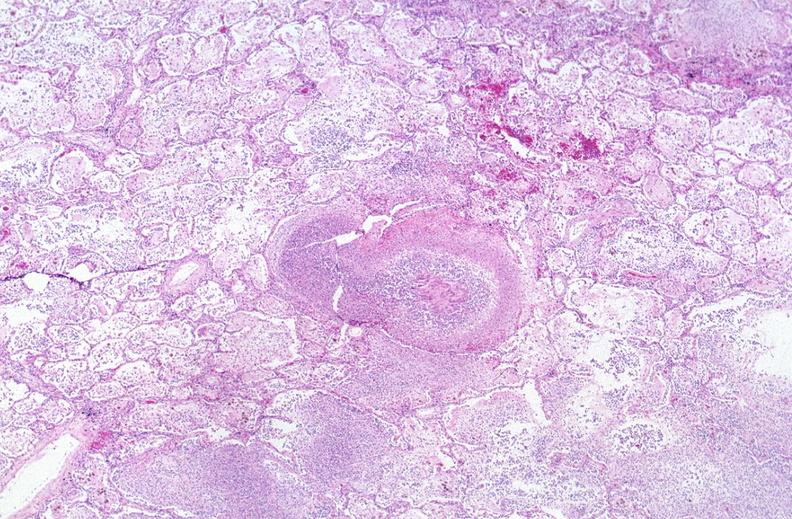does bone, clivus show lung, mycobacterium tuberculosis, granulomas and giant cells?
Answer the question using a single word or phrase. No 